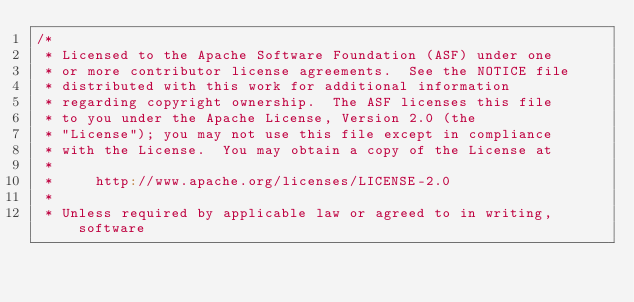<code> <loc_0><loc_0><loc_500><loc_500><_Scala_>/*
 * Licensed to the Apache Software Foundation (ASF) under one
 * or more contributor license agreements.  See the NOTICE file
 * distributed with this work for additional information
 * regarding copyright ownership.  The ASF licenses this file
 * to you under the Apache License, Version 2.0 (the
 * "License"); you may not use this file except in compliance
 * with the License.  You may obtain a copy of the License at
 *
 *     http://www.apache.org/licenses/LICENSE-2.0
 *
 * Unless required by applicable law or agreed to in writing, software</code> 